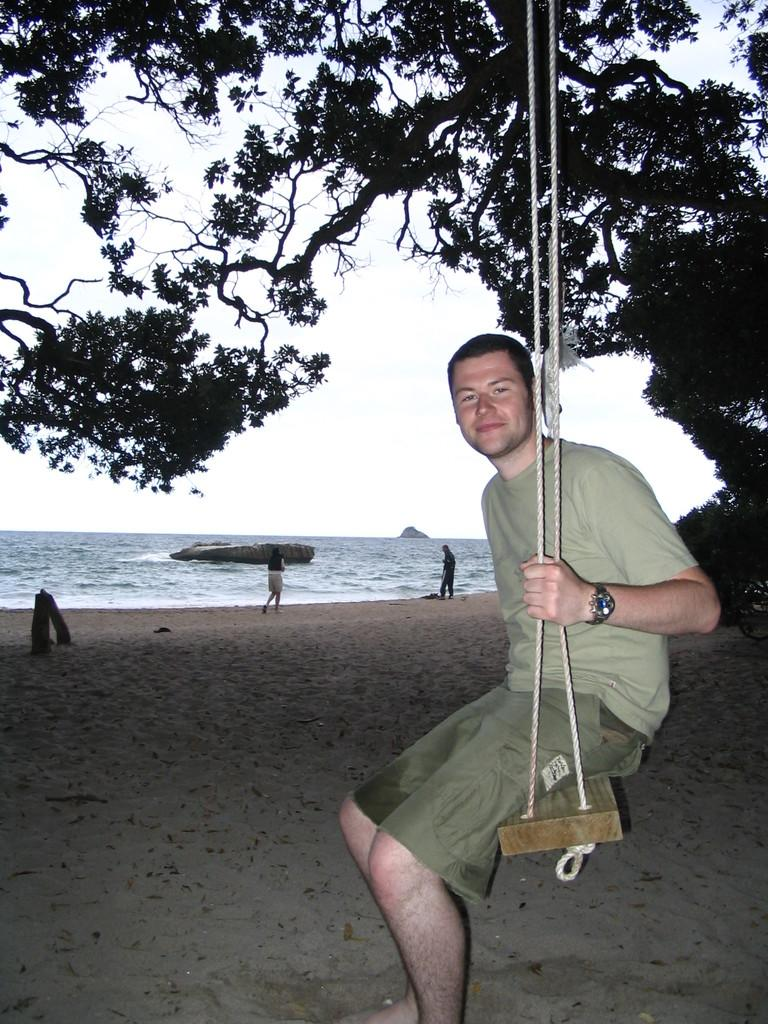Who can be seen in the image? There are people in the image. What is the man in the image doing? The man is sitting on a swing. On which side of the image is the man sitting? The man is on the right side of the image. What can be seen in the background of the image? There are trees and water visible in the background of the image. What type of pancake is the man wearing on his head in the image? There is no pancake present in the image, and the man is not wearing anything on his head. 